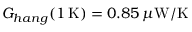Convert formula to latex. <formula><loc_0><loc_0><loc_500><loc_500>G _ { h a n g } ( 1 \, K ) = 0 . 8 5 \, \mu W / K</formula> 